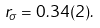<formula> <loc_0><loc_0><loc_500><loc_500>r _ { \sigma } = 0 . 3 4 ( 2 ) .</formula> 